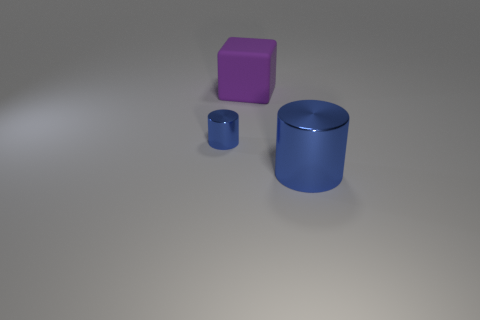Add 1 tiny purple things. How many objects exist? 4 Subtract all cubes. How many objects are left? 2 Subtract all purple objects. Subtract all big shiny things. How many objects are left? 1 Add 3 large purple objects. How many large purple objects are left? 4 Add 3 large blocks. How many large blocks exist? 4 Subtract 0 blue cubes. How many objects are left? 3 